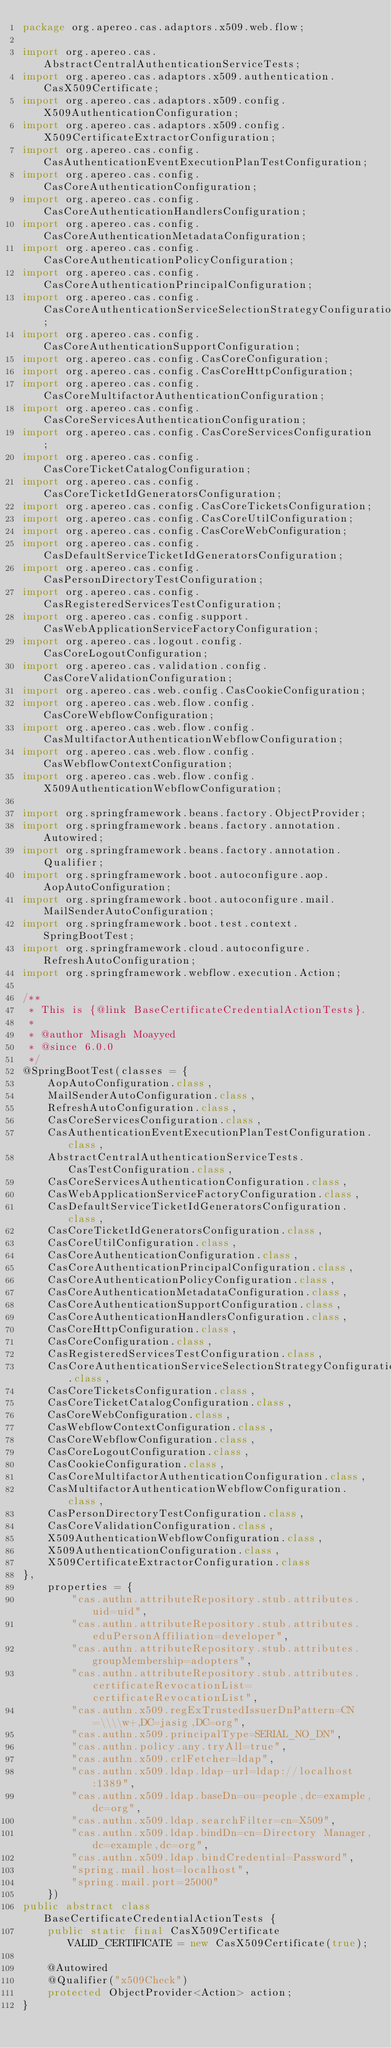Convert code to text. <code><loc_0><loc_0><loc_500><loc_500><_Java_>package org.apereo.cas.adaptors.x509.web.flow;

import org.apereo.cas.AbstractCentralAuthenticationServiceTests;
import org.apereo.cas.adaptors.x509.authentication.CasX509Certificate;
import org.apereo.cas.adaptors.x509.config.X509AuthenticationConfiguration;
import org.apereo.cas.adaptors.x509.config.X509CertificateExtractorConfiguration;
import org.apereo.cas.config.CasAuthenticationEventExecutionPlanTestConfiguration;
import org.apereo.cas.config.CasCoreAuthenticationConfiguration;
import org.apereo.cas.config.CasCoreAuthenticationHandlersConfiguration;
import org.apereo.cas.config.CasCoreAuthenticationMetadataConfiguration;
import org.apereo.cas.config.CasCoreAuthenticationPolicyConfiguration;
import org.apereo.cas.config.CasCoreAuthenticationPrincipalConfiguration;
import org.apereo.cas.config.CasCoreAuthenticationServiceSelectionStrategyConfiguration;
import org.apereo.cas.config.CasCoreAuthenticationSupportConfiguration;
import org.apereo.cas.config.CasCoreConfiguration;
import org.apereo.cas.config.CasCoreHttpConfiguration;
import org.apereo.cas.config.CasCoreMultifactorAuthenticationConfiguration;
import org.apereo.cas.config.CasCoreServicesAuthenticationConfiguration;
import org.apereo.cas.config.CasCoreServicesConfiguration;
import org.apereo.cas.config.CasCoreTicketCatalogConfiguration;
import org.apereo.cas.config.CasCoreTicketIdGeneratorsConfiguration;
import org.apereo.cas.config.CasCoreTicketsConfiguration;
import org.apereo.cas.config.CasCoreUtilConfiguration;
import org.apereo.cas.config.CasCoreWebConfiguration;
import org.apereo.cas.config.CasDefaultServiceTicketIdGeneratorsConfiguration;
import org.apereo.cas.config.CasPersonDirectoryTestConfiguration;
import org.apereo.cas.config.CasRegisteredServicesTestConfiguration;
import org.apereo.cas.config.support.CasWebApplicationServiceFactoryConfiguration;
import org.apereo.cas.logout.config.CasCoreLogoutConfiguration;
import org.apereo.cas.validation.config.CasCoreValidationConfiguration;
import org.apereo.cas.web.config.CasCookieConfiguration;
import org.apereo.cas.web.flow.config.CasCoreWebflowConfiguration;
import org.apereo.cas.web.flow.config.CasMultifactorAuthenticationWebflowConfiguration;
import org.apereo.cas.web.flow.config.CasWebflowContextConfiguration;
import org.apereo.cas.web.flow.config.X509AuthenticationWebflowConfiguration;

import org.springframework.beans.factory.ObjectProvider;
import org.springframework.beans.factory.annotation.Autowired;
import org.springframework.beans.factory.annotation.Qualifier;
import org.springframework.boot.autoconfigure.aop.AopAutoConfiguration;
import org.springframework.boot.autoconfigure.mail.MailSenderAutoConfiguration;
import org.springframework.boot.test.context.SpringBootTest;
import org.springframework.cloud.autoconfigure.RefreshAutoConfiguration;
import org.springframework.webflow.execution.Action;

/**
 * This is {@link BaseCertificateCredentialActionTests}.
 *
 * @author Misagh Moayyed
 * @since 6.0.0
 */
@SpringBootTest(classes = {
    AopAutoConfiguration.class,
    MailSenderAutoConfiguration.class,
    RefreshAutoConfiguration.class,
    CasCoreServicesConfiguration.class,
    CasAuthenticationEventExecutionPlanTestConfiguration.class,
    AbstractCentralAuthenticationServiceTests.CasTestConfiguration.class,
    CasCoreServicesAuthenticationConfiguration.class,
    CasWebApplicationServiceFactoryConfiguration.class,
    CasDefaultServiceTicketIdGeneratorsConfiguration.class,
    CasCoreTicketIdGeneratorsConfiguration.class,
    CasCoreUtilConfiguration.class,
    CasCoreAuthenticationConfiguration.class,
    CasCoreAuthenticationPrincipalConfiguration.class,
    CasCoreAuthenticationPolicyConfiguration.class,
    CasCoreAuthenticationMetadataConfiguration.class,
    CasCoreAuthenticationSupportConfiguration.class,
    CasCoreAuthenticationHandlersConfiguration.class,
    CasCoreHttpConfiguration.class,
    CasCoreConfiguration.class,
    CasRegisteredServicesTestConfiguration.class,
    CasCoreAuthenticationServiceSelectionStrategyConfiguration.class,
    CasCoreTicketsConfiguration.class,
    CasCoreTicketCatalogConfiguration.class,
    CasCoreWebConfiguration.class,
    CasWebflowContextConfiguration.class,
    CasCoreWebflowConfiguration.class,
    CasCoreLogoutConfiguration.class,
    CasCookieConfiguration.class,
    CasCoreMultifactorAuthenticationConfiguration.class,
    CasMultifactorAuthenticationWebflowConfiguration.class,
    CasPersonDirectoryTestConfiguration.class,
    CasCoreValidationConfiguration.class,
    X509AuthenticationWebflowConfiguration.class,
    X509AuthenticationConfiguration.class,
    X509CertificateExtractorConfiguration.class
},
    properties = {
        "cas.authn.attributeRepository.stub.attributes.uid=uid",
        "cas.authn.attributeRepository.stub.attributes.eduPersonAffiliation=developer",
        "cas.authn.attributeRepository.stub.attributes.groupMembership=adopters",
        "cas.authn.attributeRepository.stub.attributes.certificateRevocationList=certificateRevocationList",
        "cas.authn.x509.regExTrustedIssuerDnPattern=CN=\\\\w+,DC=jasig,DC=org",
        "cas.authn.x509.principalType=SERIAL_NO_DN",
        "cas.authn.policy.any.tryAll=true",
        "cas.authn.x509.crlFetcher=ldap",
        "cas.authn.x509.ldap.ldap-url=ldap://localhost:1389",
        "cas.authn.x509.ldap.baseDn=ou=people,dc=example,dc=org",
        "cas.authn.x509.ldap.searchFilter=cn=X509",
        "cas.authn.x509.ldap.bindDn=cn=Directory Manager,dc=example,dc=org",
        "cas.authn.x509.ldap.bindCredential=Password",
        "spring.mail.host=localhost",
        "spring.mail.port=25000"
    })
public abstract class BaseCertificateCredentialActionTests {
    public static final CasX509Certificate VALID_CERTIFICATE = new CasX509Certificate(true);

    @Autowired
    @Qualifier("x509Check")
    protected ObjectProvider<Action> action;
}
</code> 